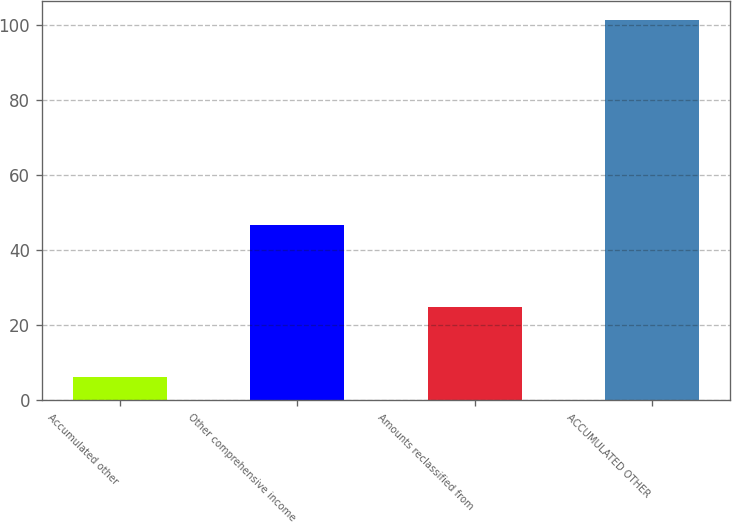<chart> <loc_0><loc_0><loc_500><loc_500><bar_chart><fcel>Accumulated other<fcel>Other comprehensive income<fcel>Amounts reclassified from<fcel>ACCUMULATED OTHER<nl><fcel>6.2<fcel>46.7<fcel>24.98<fcel>101.5<nl></chart> 